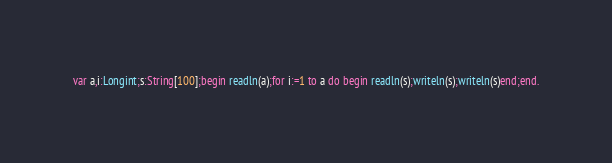<code> <loc_0><loc_0><loc_500><loc_500><_Pascal_>var a,i:Longint;s:String[100];begin readln(a);for i:=1 to a do begin readln(s);writeln(s);writeln(s)end;end.</code> 